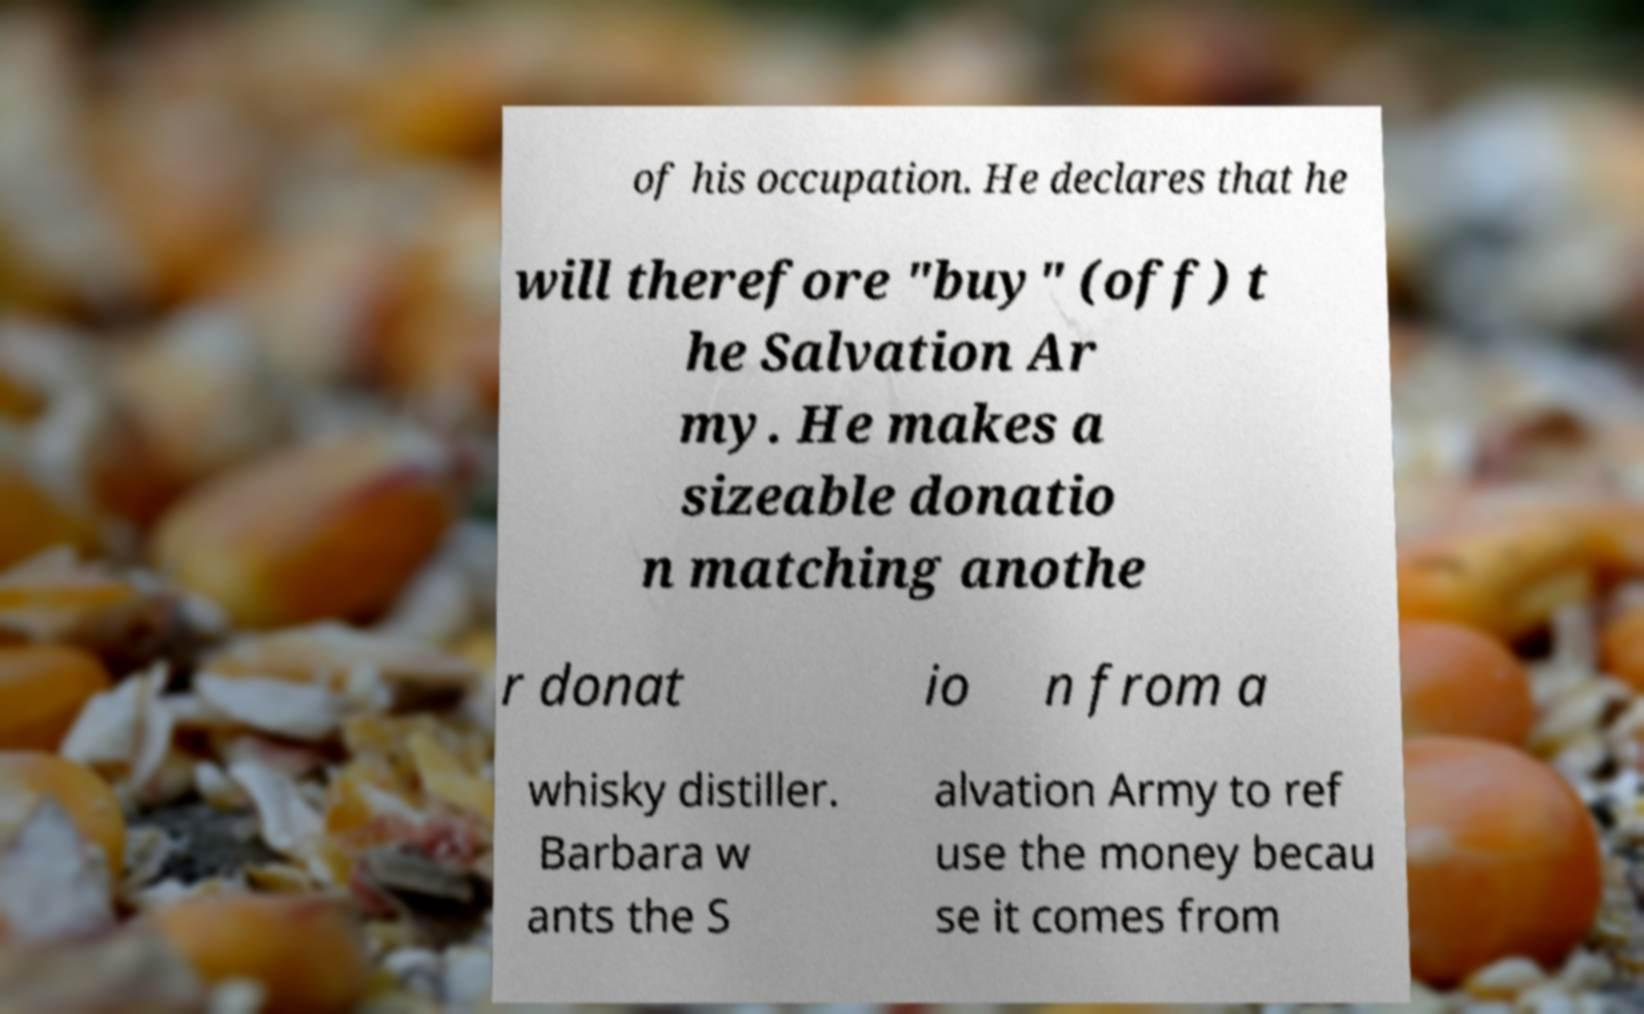Could you extract and type out the text from this image? of his occupation. He declares that he will therefore "buy" (off) t he Salvation Ar my. He makes a sizeable donatio n matching anothe r donat io n from a whisky distiller. Barbara w ants the S alvation Army to ref use the money becau se it comes from 